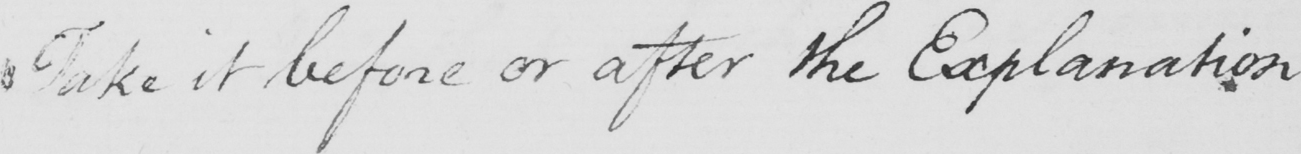What does this handwritten line say? Take it before or after the Explanation 